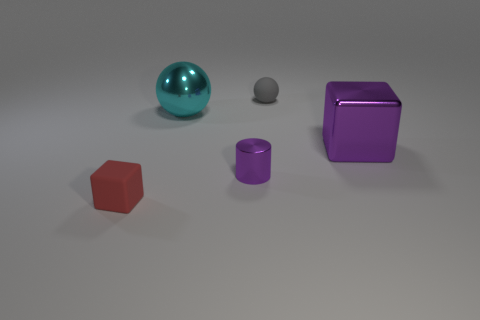Could you describe the colors and shapes of the objects in the image? Certainly! The image portrays a variety of geometric shapes: a red hexahedron, a teal sphere, a grey sphere smaller in size, a purple cylinder, and a reflective purple cube. Each object is distinct in both color and form. 